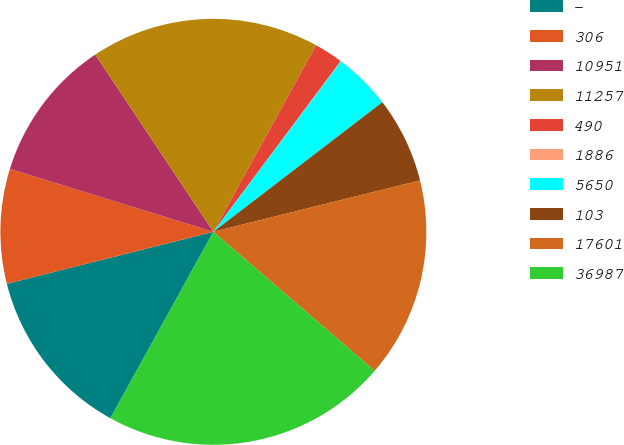Convert chart. <chart><loc_0><loc_0><loc_500><loc_500><pie_chart><fcel>-<fcel>306<fcel>10951<fcel>11257<fcel>490<fcel>1886<fcel>5650<fcel>103<fcel>17601<fcel>36987<nl><fcel>13.04%<fcel>8.7%<fcel>10.87%<fcel>17.37%<fcel>2.19%<fcel>0.03%<fcel>4.36%<fcel>6.53%<fcel>15.2%<fcel>21.71%<nl></chart> 